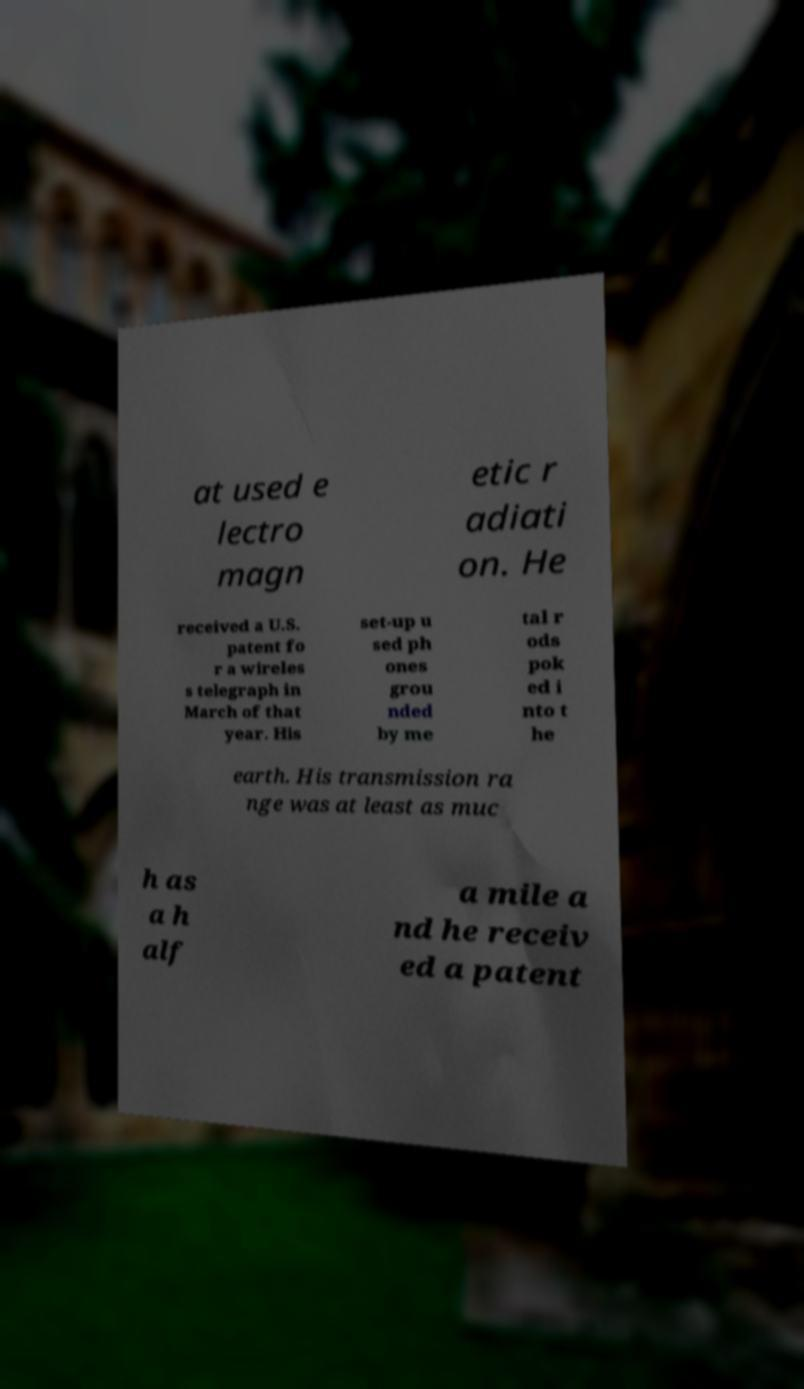Can you accurately transcribe the text from the provided image for me? at used e lectro magn etic r adiati on. He received a U.S. patent fo r a wireles s telegraph in March of that year. His set-up u sed ph ones grou nded by me tal r ods pok ed i nto t he earth. His transmission ra nge was at least as muc h as a h alf a mile a nd he receiv ed a patent 